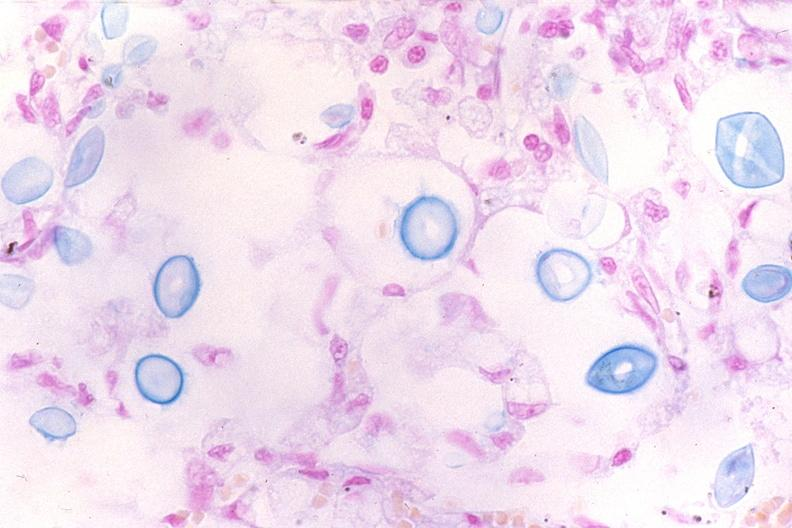what does this image show?
Answer the question using a single word or phrase. Lung 